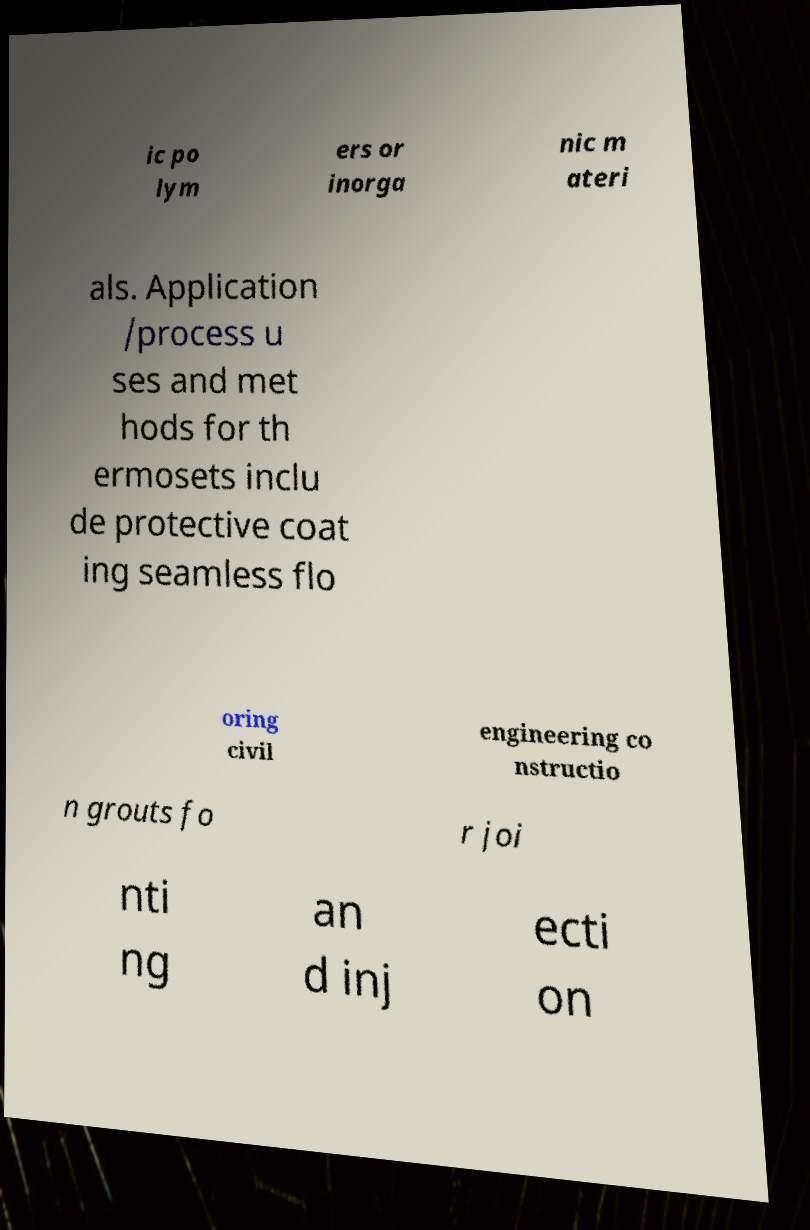I need the written content from this picture converted into text. Can you do that? ic po lym ers or inorga nic m ateri als. Application /process u ses and met hods for th ermosets inclu de protective coat ing seamless flo oring civil engineering co nstructio n grouts fo r joi nti ng an d inj ecti on 